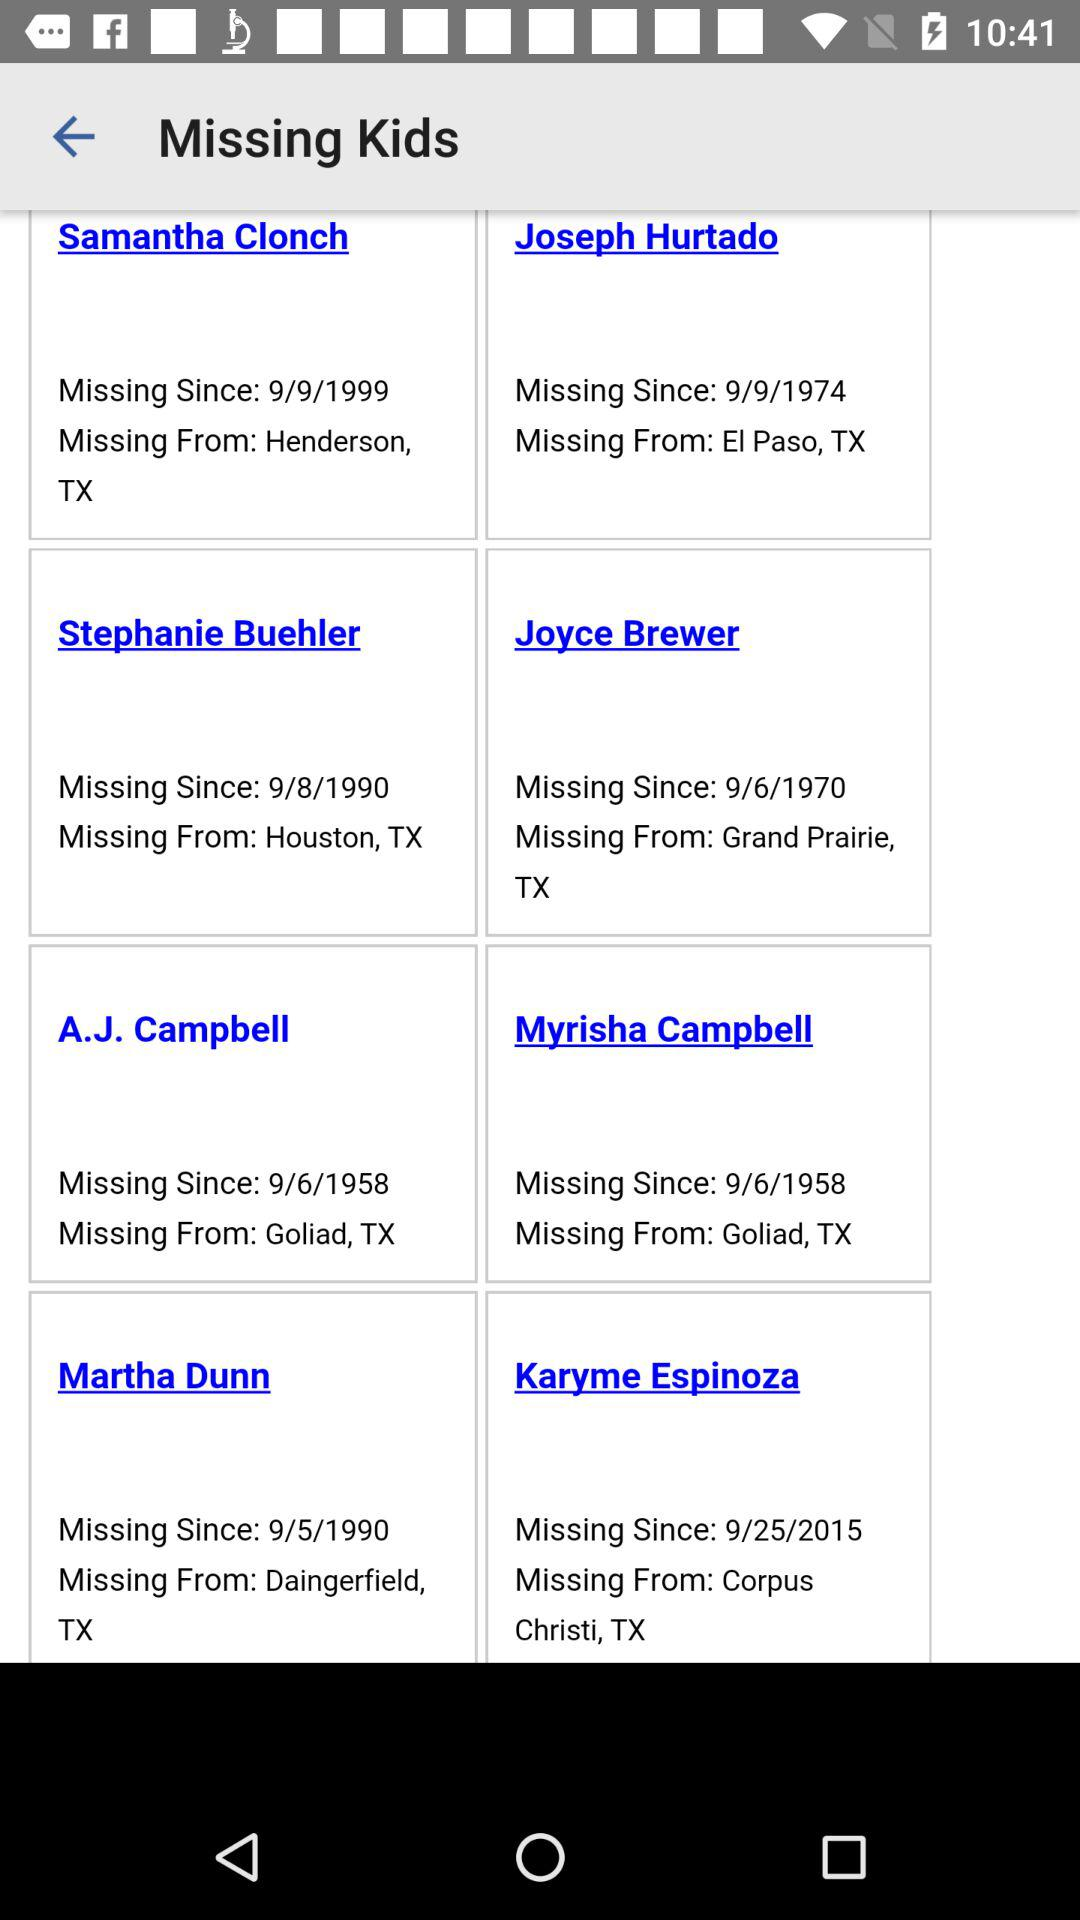What is the missing place for Joyce Brewer? The missing place for Joyce Brewer is Grand Prairie, TX. 